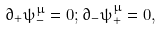<formula> <loc_0><loc_0><loc_500><loc_500>\partial _ { + } \psi ^ { \mu } _ { - } = 0 ; \partial _ { - } \psi ^ { \mu } _ { + } = 0 ,</formula> 